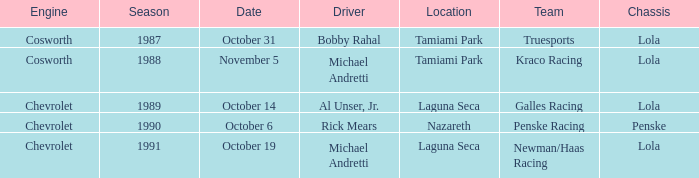What engine does Galles Racing use? Chevrolet. 